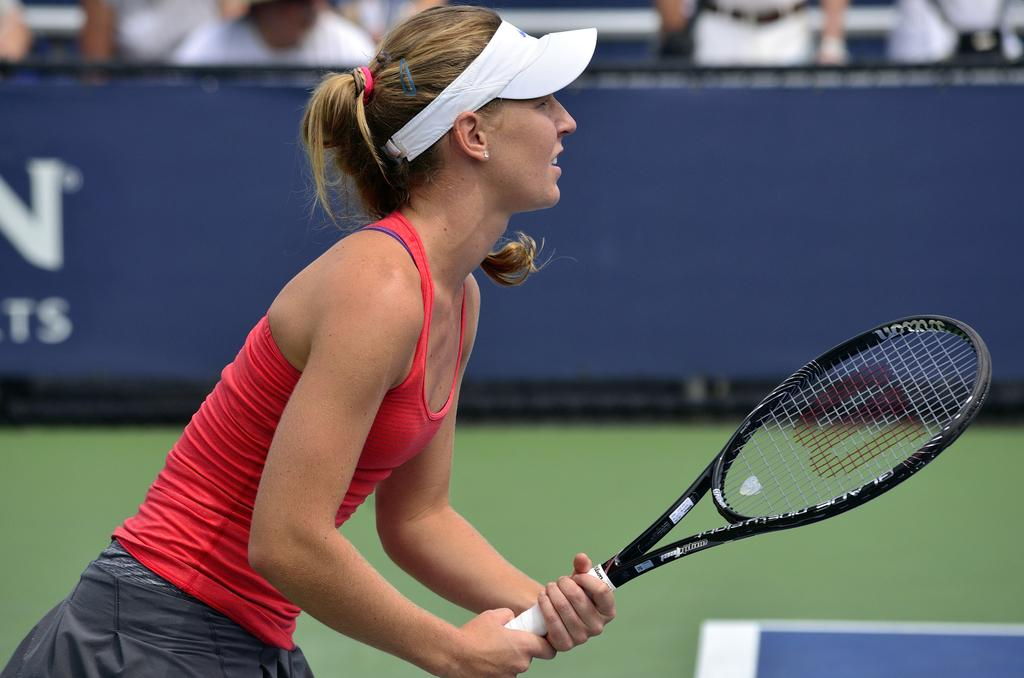What object is the woman holding in the image? The woman is holding a tennis racket. What can be seen in the background of the image? There is a blue banner in the background. What is written on the blue banner? Unfortunately, the specific text on the blue banner cannot be determined from the image. How does the woman's income affect her ability to play tennis in the image? There is no information about the woman's income in the image, so it cannot be determined how it might affect her ability to play tennis. 